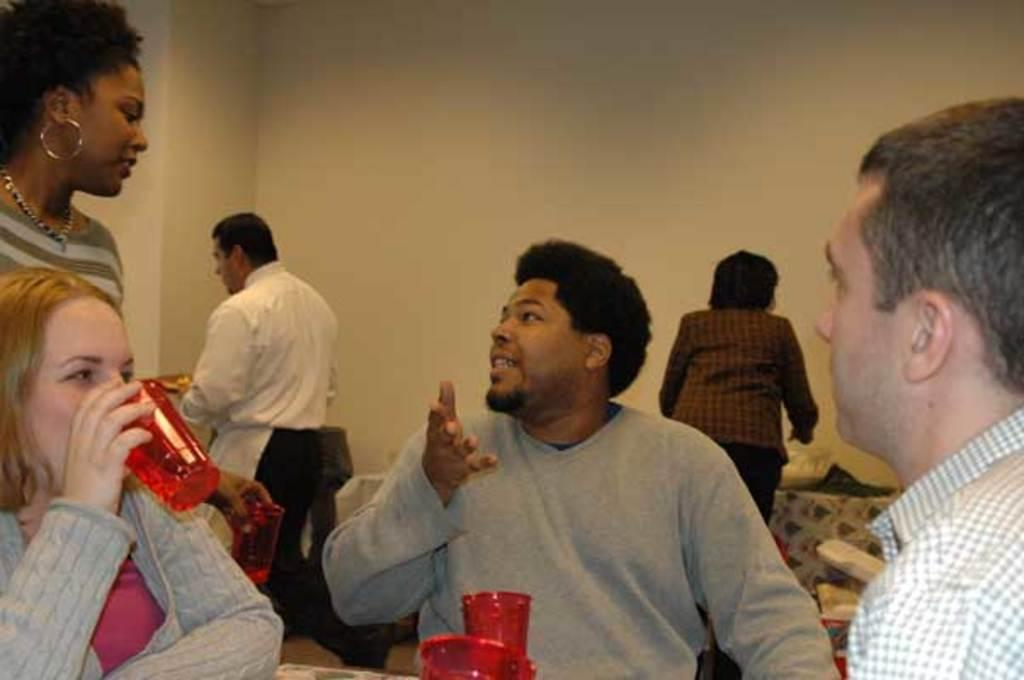What are the three people in the image doing? The three people are sitting on cars. Can you describe the background of the image? There are other persons in the background. What can be seen in the image besides the people and cars? There is a wall visible in the image. What type of glue is being used by the people sitting on the cars? There is no glue present in the image, and the people sitting on the cars are not using any glue. Where is the lunchroom located in the image? There is no mention of a lunchroom in the image, so its location cannot be determined. 